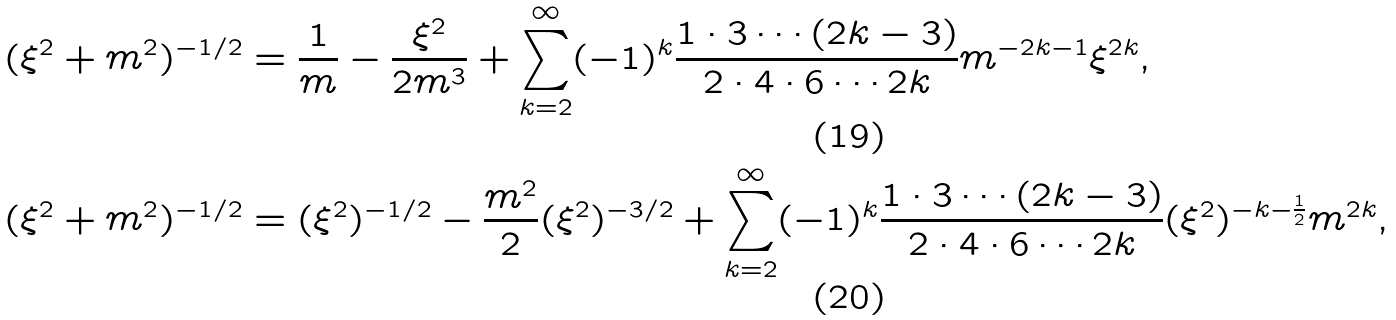Convert formula to latex. <formula><loc_0><loc_0><loc_500><loc_500>( \xi ^ { 2 } + m ^ { 2 } ) ^ { - 1 / 2 } & = \frac { 1 } { m } - \frac { \xi ^ { 2 } } { 2 m ^ { 3 } } + \sum _ { k = 2 } ^ { \infty } ( - 1 ) ^ { k } \frac { 1 \cdot 3 \cdots ( 2 k - 3 ) } { 2 \cdot 4 \cdot 6 \cdots 2 k } m ^ { - 2 k - 1 } \xi ^ { 2 k } , \\ ( \xi ^ { 2 } + m ^ { 2 } ) ^ { - 1 / 2 } & = ( \xi ^ { 2 } ) ^ { - 1 / 2 } - \frac { m ^ { 2 } } { 2 } ( \xi ^ { 2 } ) ^ { - 3 / 2 } + \sum _ { k = 2 } ^ { \infty } ( - 1 ) ^ { k } \frac { 1 \cdot 3 \cdots ( 2 k - 3 ) } { 2 \cdot 4 \cdot 6 \cdots 2 k } ( \xi ^ { 2 } ) ^ { - k - \frac { 1 } { 2 } } m ^ { 2 k } ,</formula> 